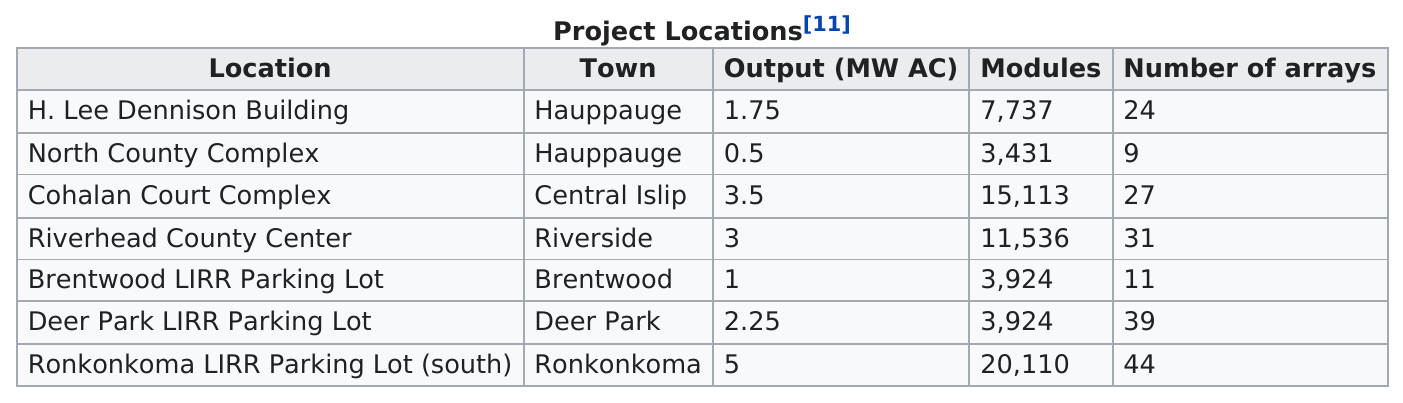Specify some key components in this picture. The Deer Park LIRR Parking Lot has a higher number of arrays than North County. The total output of all seven projects is 17 megawatts. The Ronkonkoma LIRR Parking Lot (south) has the highest number of modules, and it is located in the location that has the highest number of modules, cohalan ourt or ronkonkoma? The town of Hauppauge was the only town with two project locations. The North County Complex project has the lowest outcome compared to the other project locations. 